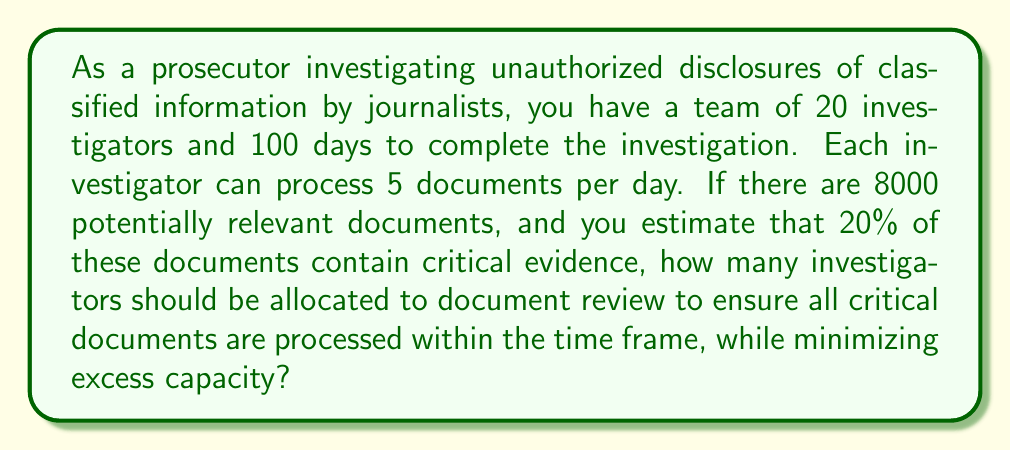Provide a solution to this math problem. Let's approach this problem step-by-step:

1) First, let's calculate the total number of critical documents:
   $20\% \text{ of } 8000 = 0.2 \times 8000 = 1600$ critical documents

2) Now, let's determine the total investigator-days available:
   $20 \text{ investigators} \times 100 \text{ days} = 2000$ investigator-days

3) Each investigator can process 5 documents per day, so we need to find $x$, the number of investigators needed:

   $$\frac{1600 \text{ critical documents}}{5 \text{ documents per investigator per day} \times 100 \text{ days}} = x \text{ investigators}$$

4) Solving for $x$:
   
   $$x = \frac{1600}{5 \times 100} = \frac{1600}{500} = 3.2$$

5) Since we can't allocate a fractional investigator, we round up to the nearest whole number:
   $x = 4$ investigators

6) Let's verify that 4 investigators can process all critical documents:
   $4 \text{ investigators} \times 5 \text{ documents/day} \times 100 \text{ days} = 2000 \text{ documents}$

   This is more than the 1600 critical documents, ensuring all are processed.

7) To check for minimal excess capacity, let's calculate the excess:
   $2000 - 1600 = 400 \text{ documents}$, which is less than what would be processed by adding another investigator $(500 \text{ documents})$.

Therefore, allocating 4 investigators to document review is optimal.
Answer: 4 investigators 